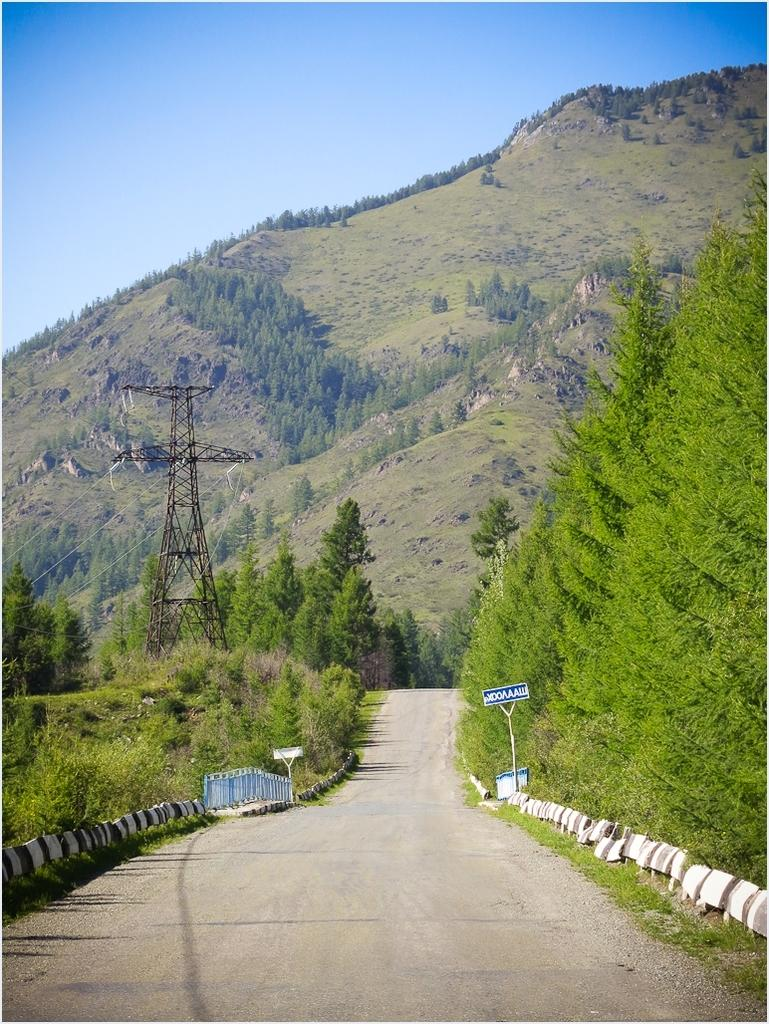What is attached to the poles in the image? There are boards attached to poles in the image. What type of natural vegetation can be seen in the image? There are trees in the image. What type of barrier is present in the image? There is a fence in the image. What tall structure is visible in the image? There is a tower in the image. What type of elevated land feature is present in the image? There is a hill in the image. What is visible in the background of the image? The sky is visible in the background of the image. What type of competition is taking place on the hill in the image? There is no competition present in the image; it only shows boards attached to poles, trees, a fence, a tower, a hill, and the sky. What is the current situation of the trees in the image? There is no information about the current situation of the trees in the image. 